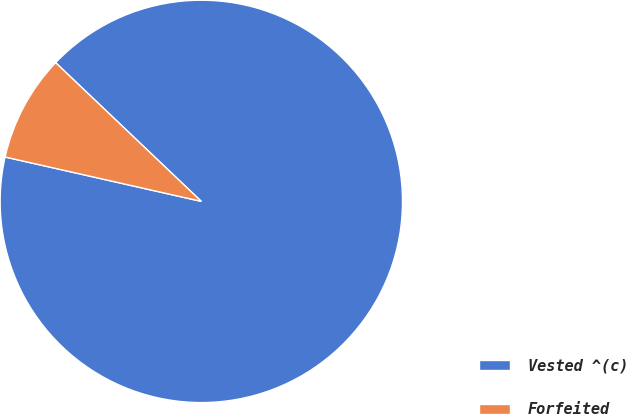Convert chart. <chart><loc_0><loc_0><loc_500><loc_500><pie_chart><fcel>Vested ^(c)<fcel>Forfeited<nl><fcel>91.43%<fcel>8.57%<nl></chart> 